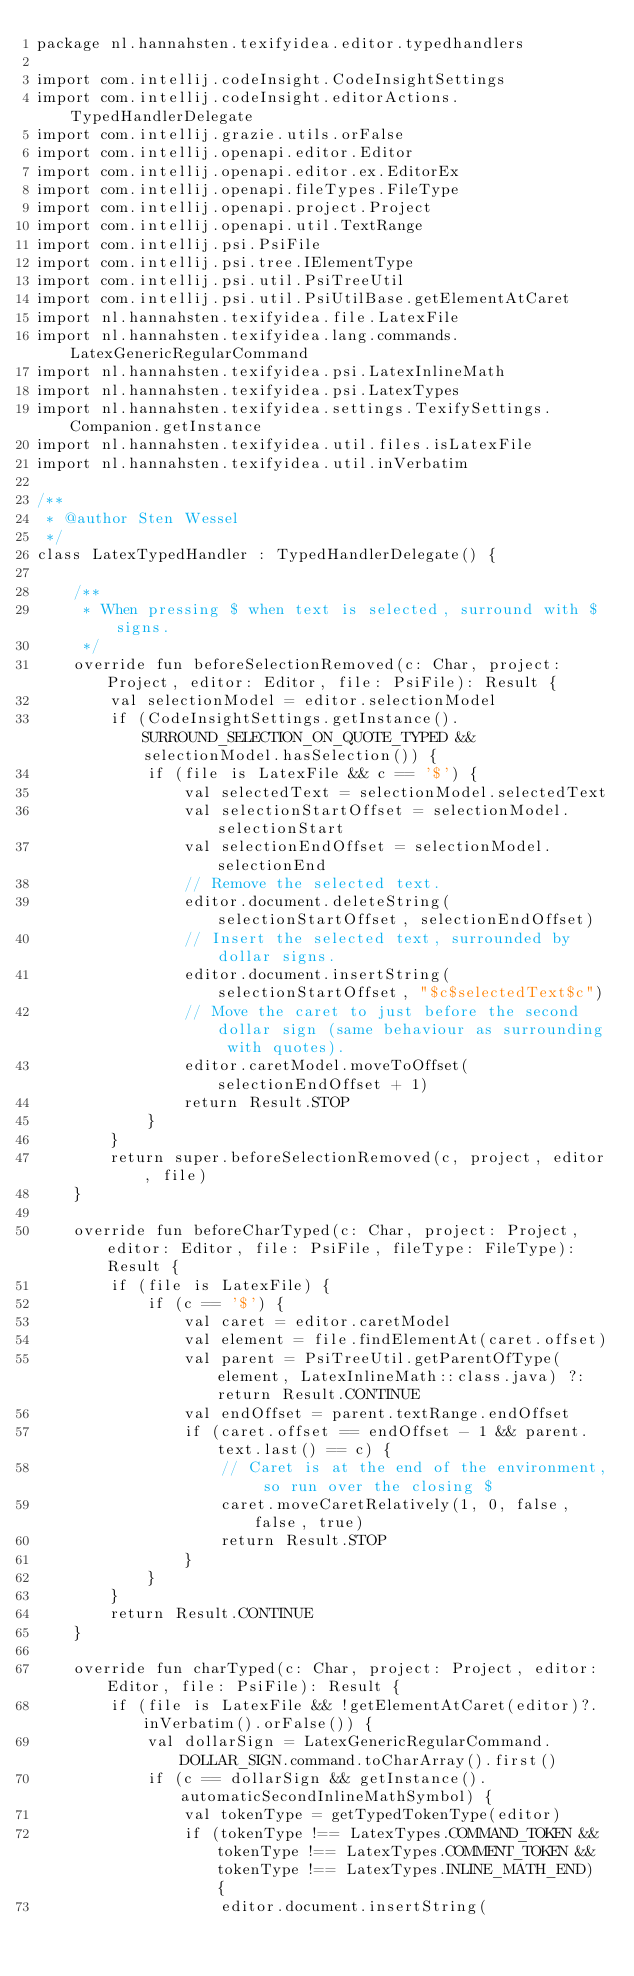<code> <loc_0><loc_0><loc_500><loc_500><_Kotlin_>package nl.hannahsten.texifyidea.editor.typedhandlers

import com.intellij.codeInsight.CodeInsightSettings
import com.intellij.codeInsight.editorActions.TypedHandlerDelegate
import com.intellij.grazie.utils.orFalse
import com.intellij.openapi.editor.Editor
import com.intellij.openapi.editor.ex.EditorEx
import com.intellij.openapi.fileTypes.FileType
import com.intellij.openapi.project.Project
import com.intellij.openapi.util.TextRange
import com.intellij.psi.PsiFile
import com.intellij.psi.tree.IElementType
import com.intellij.psi.util.PsiTreeUtil
import com.intellij.psi.util.PsiUtilBase.getElementAtCaret
import nl.hannahsten.texifyidea.file.LatexFile
import nl.hannahsten.texifyidea.lang.commands.LatexGenericRegularCommand
import nl.hannahsten.texifyidea.psi.LatexInlineMath
import nl.hannahsten.texifyidea.psi.LatexTypes
import nl.hannahsten.texifyidea.settings.TexifySettings.Companion.getInstance
import nl.hannahsten.texifyidea.util.files.isLatexFile
import nl.hannahsten.texifyidea.util.inVerbatim

/**
 * @author Sten Wessel
 */
class LatexTypedHandler : TypedHandlerDelegate() {

    /**
     * When pressing $ when text is selected, surround with $ signs.
     */
    override fun beforeSelectionRemoved(c: Char, project: Project, editor: Editor, file: PsiFile): Result {
        val selectionModel = editor.selectionModel
        if (CodeInsightSettings.getInstance().SURROUND_SELECTION_ON_QUOTE_TYPED && selectionModel.hasSelection()) {
            if (file is LatexFile && c == '$') {
                val selectedText = selectionModel.selectedText
                val selectionStartOffset = selectionModel.selectionStart
                val selectionEndOffset = selectionModel.selectionEnd
                // Remove the selected text.
                editor.document.deleteString(selectionStartOffset, selectionEndOffset)
                // Insert the selected text, surrounded by dollar signs.
                editor.document.insertString(selectionStartOffset, "$c$selectedText$c")
                // Move the caret to just before the second dollar sign (same behaviour as surrounding with quotes).
                editor.caretModel.moveToOffset(selectionEndOffset + 1)
                return Result.STOP
            }
        }
        return super.beforeSelectionRemoved(c, project, editor, file)
    }

    override fun beforeCharTyped(c: Char, project: Project, editor: Editor, file: PsiFile, fileType: FileType): Result {
        if (file is LatexFile) {
            if (c == '$') {
                val caret = editor.caretModel
                val element = file.findElementAt(caret.offset)
                val parent = PsiTreeUtil.getParentOfType(element, LatexInlineMath::class.java) ?: return Result.CONTINUE
                val endOffset = parent.textRange.endOffset
                if (caret.offset == endOffset - 1 && parent.text.last() == c) {
                    // Caret is at the end of the environment, so run over the closing $
                    caret.moveCaretRelatively(1, 0, false, false, true)
                    return Result.STOP
                }
            }
        }
        return Result.CONTINUE
    }

    override fun charTyped(c: Char, project: Project, editor: Editor, file: PsiFile): Result {
        if (file is LatexFile && !getElementAtCaret(editor)?.inVerbatim().orFalse()) {
            val dollarSign = LatexGenericRegularCommand.DOLLAR_SIGN.command.toCharArray().first()
            if (c == dollarSign && getInstance().automaticSecondInlineMathSymbol) {
                val tokenType = getTypedTokenType(editor)
                if (tokenType !== LatexTypes.COMMAND_TOKEN && tokenType !== LatexTypes.COMMENT_TOKEN && tokenType !== LatexTypes.INLINE_MATH_END) {
                    editor.document.insertString(</code> 